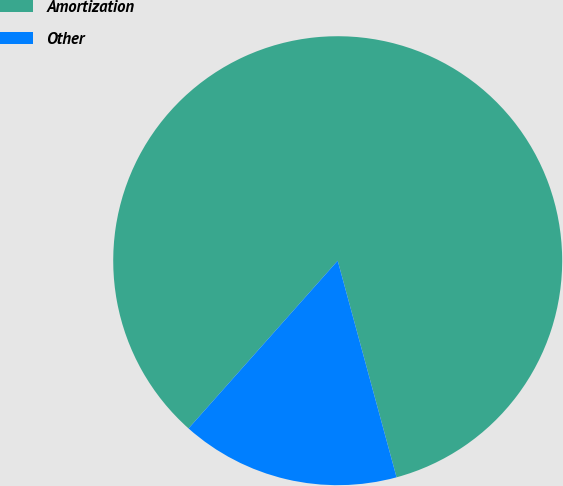Convert chart to OTSL. <chart><loc_0><loc_0><loc_500><loc_500><pie_chart><fcel>Amortization<fcel>Other<nl><fcel>84.21%<fcel>15.79%<nl></chart> 